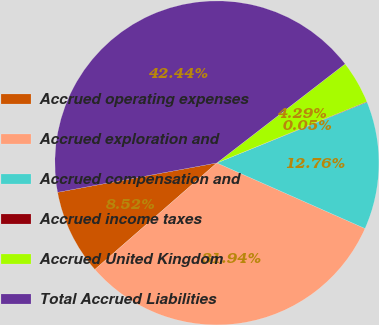Convert chart to OTSL. <chart><loc_0><loc_0><loc_500><loc_500><pie_chart><fcel>Accrued operating expenses<fcel>Accrued exploration and<fcel>Accrued compensation and<fcel>Accrued income taxes<fcel>Accrued United Kingdom<fcel>Total Accrued Liabilities<nl><fcel>8.52%<fcel>31.94%<fcel>12.76%<fcel>0.05%<fcel>4.29%<fcel>42.44%<nl></chart> 